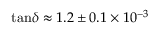Convert formula to latex. <formula><loc_0><loc_0><loc_500><loc_500>\tan \, \delta \approx 1 . 2 \pm 0 . 1 \times 1 0 ^ { - 3 }</formula> 